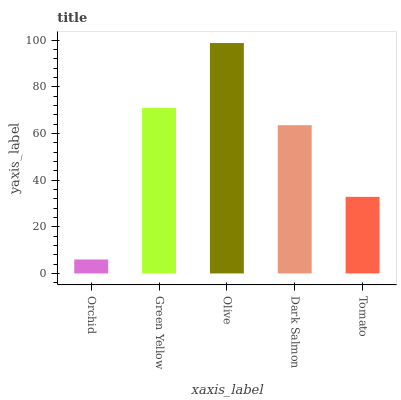Is Orchid the minimum?
Answer yes or no. Yes. Is Olive the maximum?
Answer yes or no. Yes. Is Green Yellow the minimum?
Answer yes or no. No. Is Green Yellow the maximum?
Answer yes or no. No. Is Green Yellow greater than Orchid?
Answer yes or no. Yes. Is Orchid less than Green Yellow?
Answer yes or no. Yes. Is Orchid greater than Green Yellow?
Answer yes or no. No. Is Green Yellow less than Orchid?
Answer yes or no. No. Is Dark Salmon the high median?
Answer yes or no. Yes. Is Dark Salmon the low median?
Answer yes or no. Yes. Is Orchid the high median?
Answer yes or no. No. Is Olive the low median?
Answer yes or no. No. 